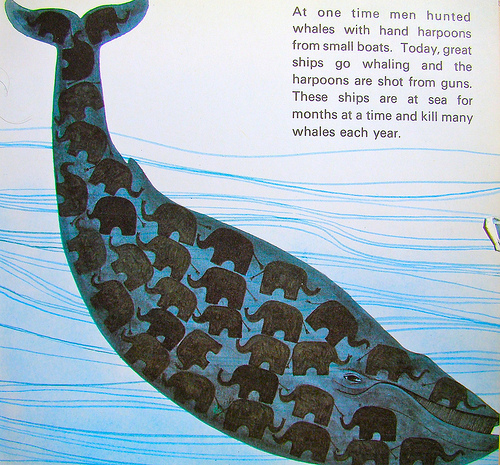<image>
Is the fish in the water? Yes. The fish is contained within or inside the water, showing a containment relationship. 